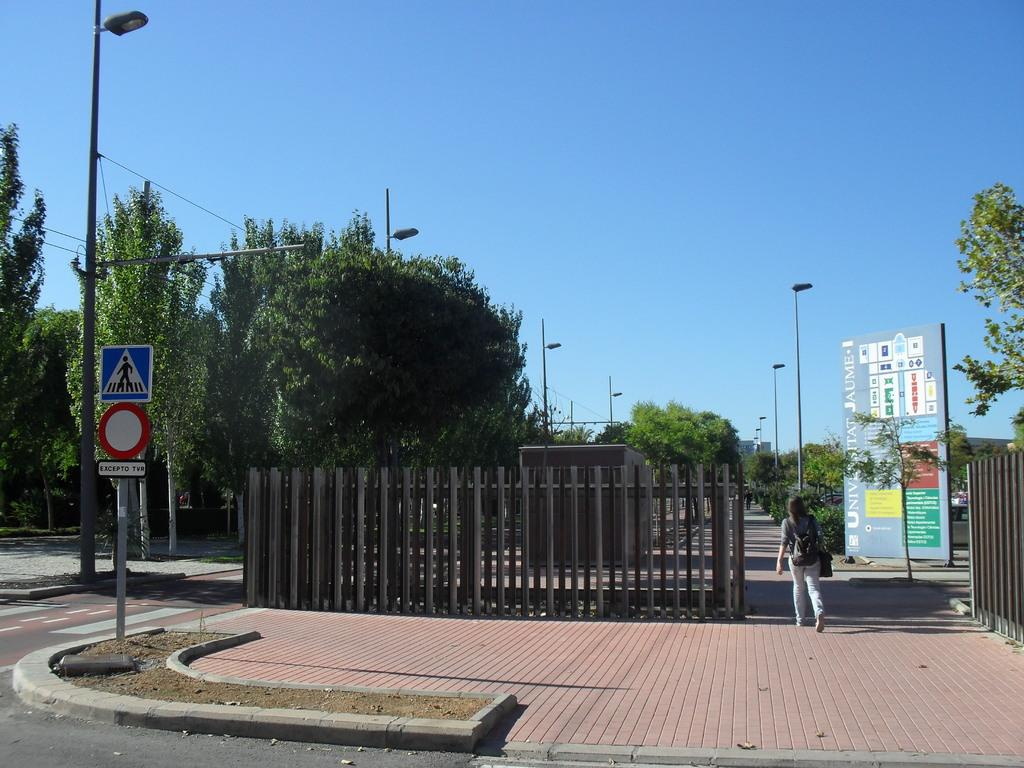What is the lady in the image doing? The lady is walking on the right side of the image. What can be seen on the left side of the image? There is a sign board on the left side of the image. What is present in the image that separates different areas? There is a fence in the image. What can be seen in the background of the image? There are trees, a pole, a board, and the sky visible in the background of the image. What type of letter is the lady holding in the image? There is no letter present in the image; the lady is simply walking. Can you see any bats flying in the image? There are no bats visible in the image; it features a lady walking, a sign board, a fence, and various background elements. 